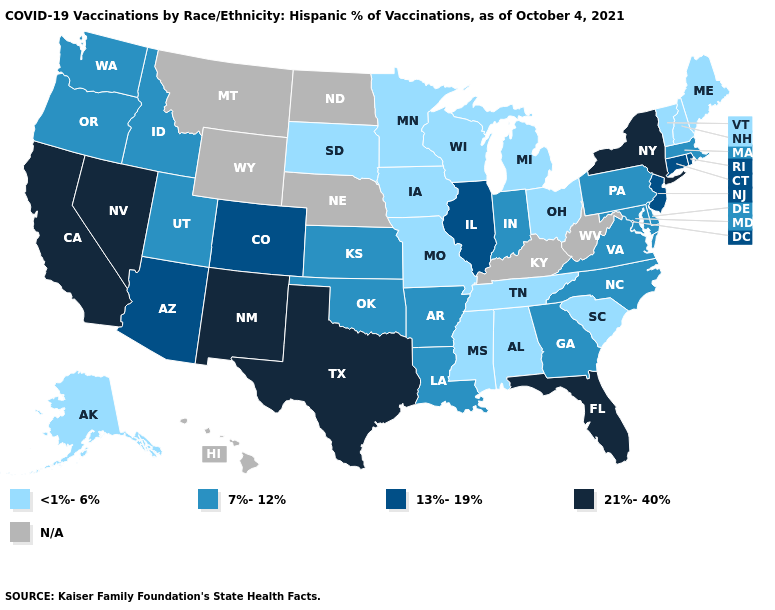Does New York have the highest value in the Northeast?
Short answer required. Yes. Name the states that have a value in the range 21%-40%?
Short answer required. California, Florida, Nevada, New Mexico, New York, Texas. What is the lowest value in the USA?
Answer briefly. <1%-6%. Name the states that have a value in the range 7%-12%?
Be succinct. Arkansas, Delaware, Georgia, Idaho, Indiana, Kansas, Louisiana, Maryland, Massachusetts, North Carolina, Oklahoma, Oregon, Pennsylvania, Utah, Virginia, Washington. What is the lowest value in states that border Florida?
Concise answer only. <1%-6%. Name the states that have a value in the range 21%-40%?
Concise answer only. California, Florida, Nevada, New Mexico, New York, Texas. What is the lowest value in states that border Illinois?
Give a very brief answer. <1%-6%. Which states hav the highest value in the Northeast?
Be succinct. New York. Which states hav the highest value in the MidWest?
Write a very short answer. Illinois. Name the states that have a value in the range 21%-40%?
Keep it brief. California, Florida, Nevada, New Mexico, New York, Texas. Does the map have missing data?
Quick response, please. Yes. What is the value of North Carolina?
Be succinct. 7%-12%. Does the first symbol in the legend represent the smallest category?
Keep it brief. Yes. 